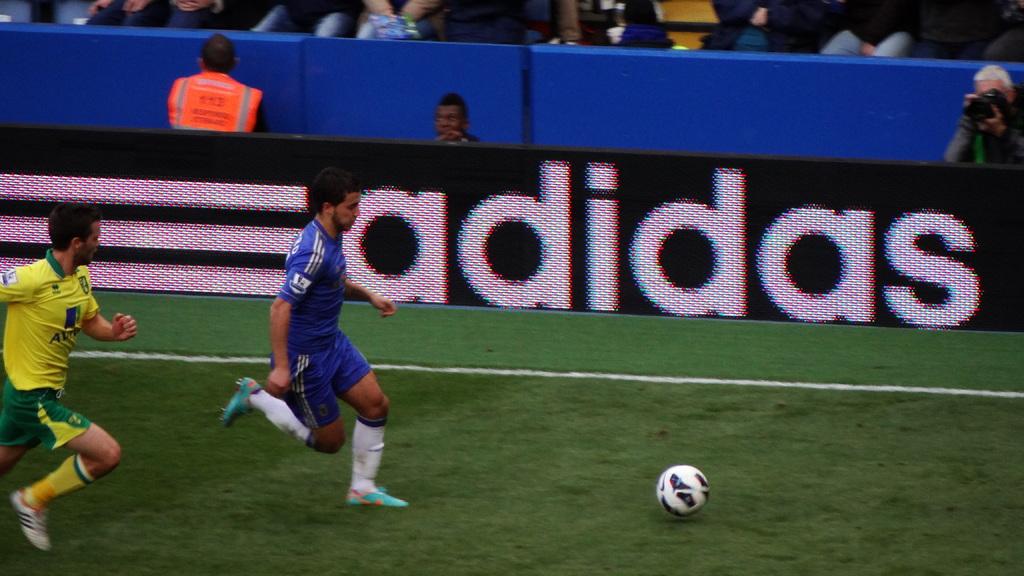What clothing company logo is displayed on the fence next to the players?
Your response must be concise. Adidas. 